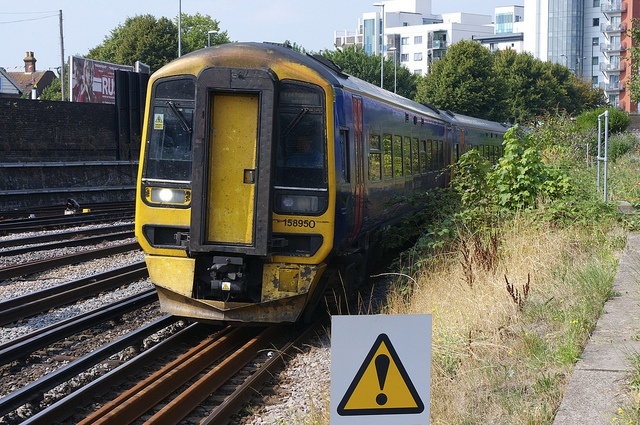Describe the objects in this image and their specific colors. I can see a train in lavender, black, gray, and olive tones in this image. 